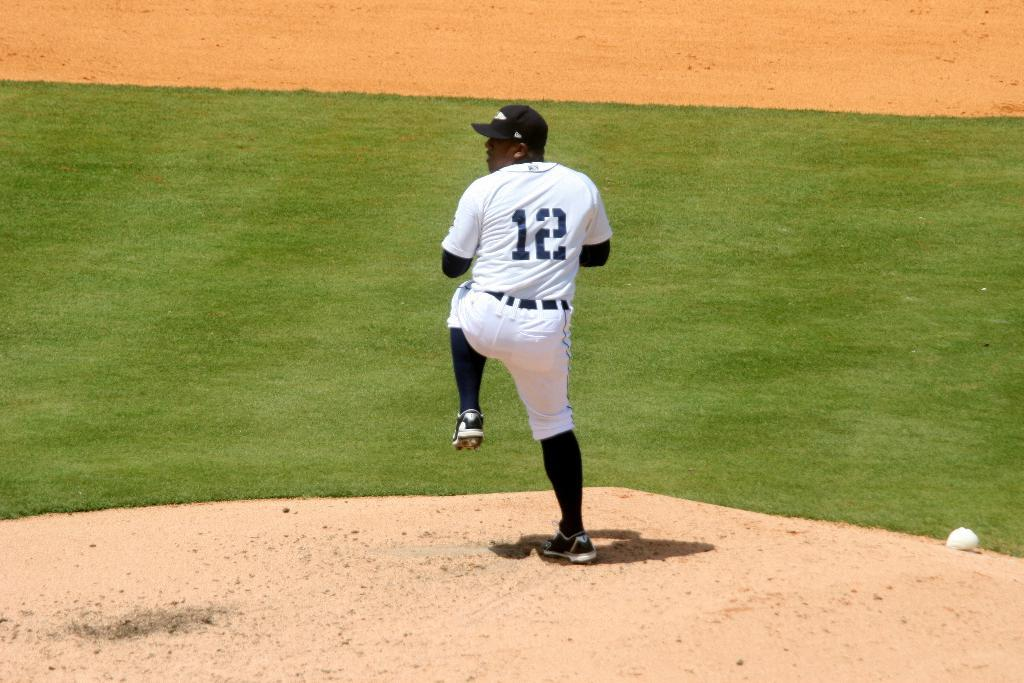<image>
Provide a brief description of the given image. Baseball pitcher in a white uniform with a black 12 on his uniform. 